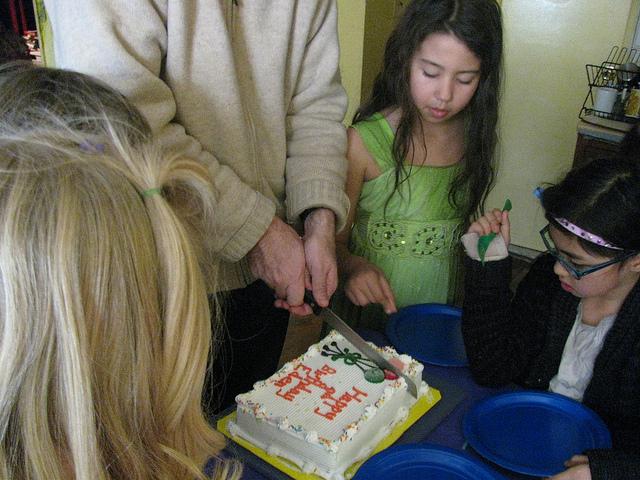What is the person cutting?
Answer briefly. Cake. Why is the person using a knife?
Write a very short answer. Cutting cake. What is she pointing to?
Concise answer only. Cake. What color are the plates?
Quick response, please. Blue. What are the kids looking at?
Write a very short answer. Cake. Is the woman enjoying her pizza?
Write a very short answer. No. What main food are they eating?
Write a very short answer. Cake. What color is the girl's dress?
Write a very short answer. Green. 